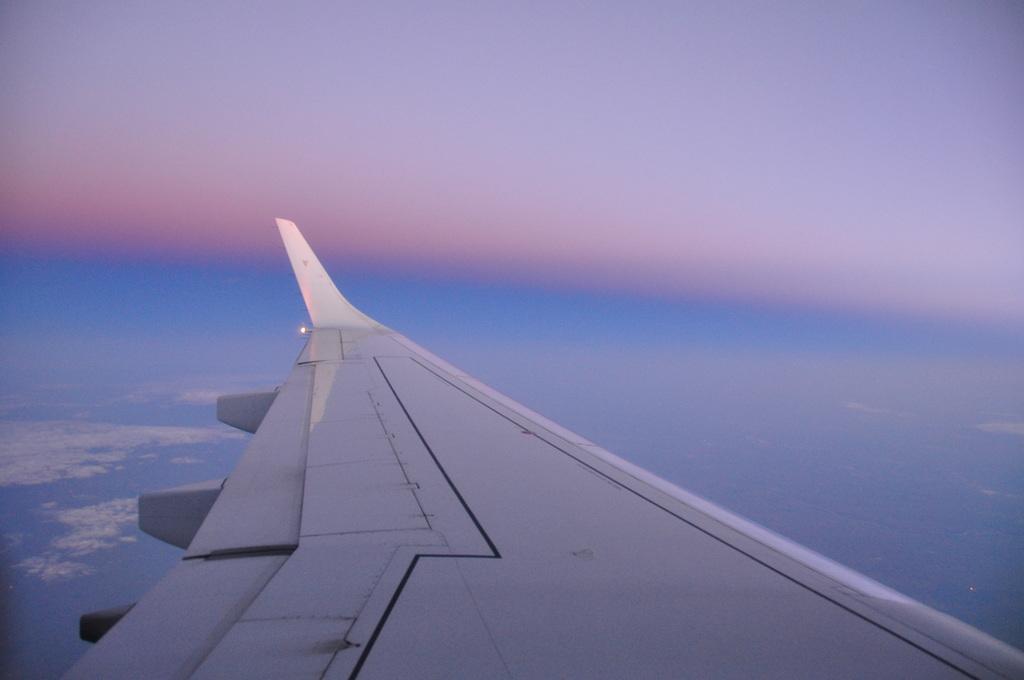How would you summarize this image in a sentence or two? In this picture we can see an airplane wing and in the background we can see the sky. 